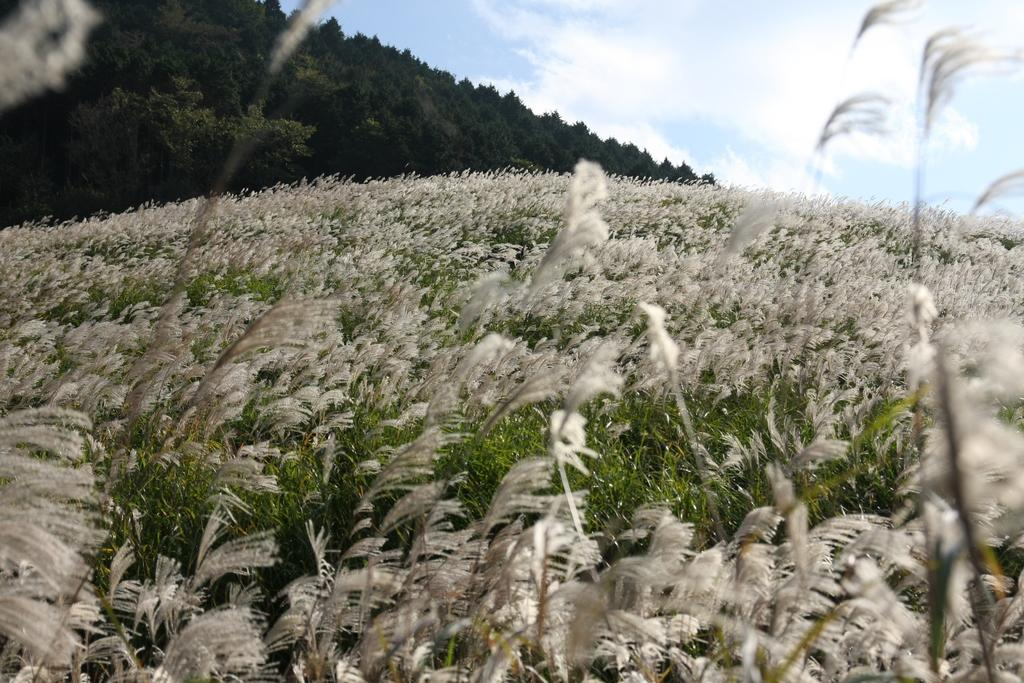What type of vegetation is visible on the surface in the image? There are grass plants visible on the surface in the image. What can be seen on the hill in the image? The hill is covered with trees in the image. How far away is the hill from the grass plants? The hill is far away from the grass plants in the image. What is visible in the background of the image? The sky is visible in the image. What is present in the sky? Clouds are present in the sky in the image. Can you see a crow flying behind the curtain in the image? There is no curtain or crow present in the image. What surprise is hidden behind the trees on the hill in the image? There is no mention of a surprise or anything hidden behind the trees in the image. 